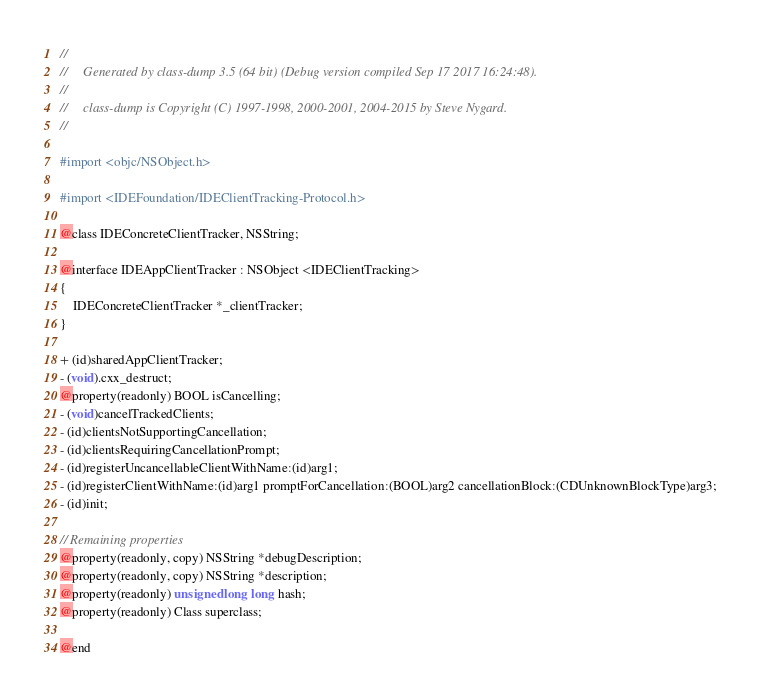<code> <loc_0><loc_0><loc_500><loc_500><_C_>//
//     Generated by class-dump 3.5 (64 bit) (Debug version compiled Sep 17 2017 16:24:48).
//
//     class-dump is Copyright (C) 1997-1998, 2000-2001, 2004-2015 by Steve Nygard.
//

#import <objc/NSObject.h>

#import <IDEFoundation/IDEClientTracking-Protocol.h>

@class IDEConcreteClientTracker, NSString;

@interface IDEAppClientTracker : NSObject <IDEClientTracking>
{
    IDEConcreteClientTracker *_clientTracker;
}

+ (id)sharedAppClientTracker;
- (void).cxx_destruct;
@property(readonly) BOOL isCancelling;
- (void)cancelTrackedClients;
- (id)clientsNotSupportingCancellation;
- (id)clientsRequiringCancellationPrompt;
- (id)registerUncancellableClientWithName:(id)arg1;
- (id)registerClientWithName:(id)arg1 promptForCancellation:(BOOL)arg2 cancellationBlock:(CDUnknownBlockType)arg3;
- (id)init;

// Remaining properties
@property(readonly, copy) NSString *debugDescription;
@property(readonly, copy) NSString *description;
@property(readonly) unsigned long long hash;
@property(readonly) Class superclass;

@end

</code> 